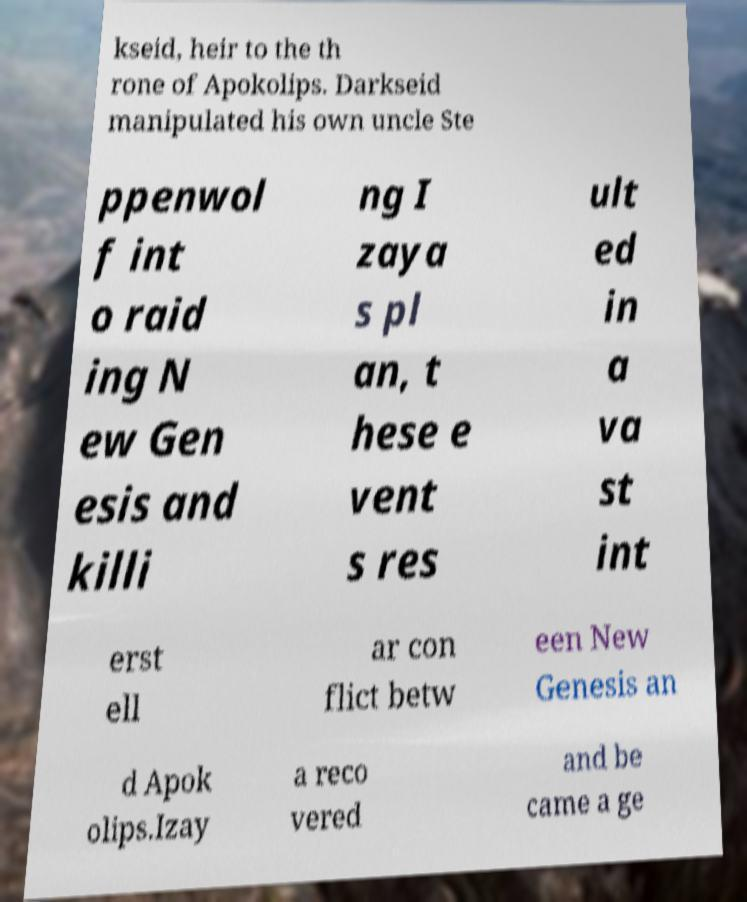What messages or text are displayed in this image? I need them in a readable, typed format. kseid, heir to the th rone of Apokolips. Darkseid manipulated his own uncle Ste ppenwol f int o raid ing N ew Gen esis and killi ng I zaya s pl an, t hese e vent s res ult ed in a va st int erst ell ar con flict betw een New Genesis an d Apok olips.Izay a reco vered and be came a ge 